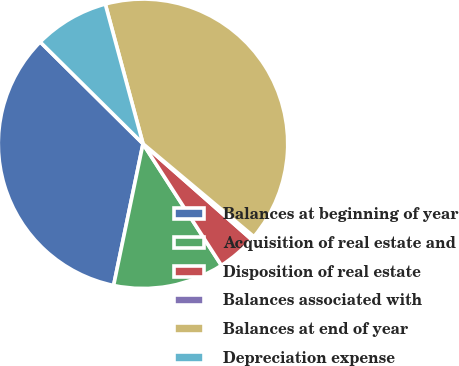Convert chart. <chart><loc_0><loc_0><loc_500><loc_500><pie_chart><fcel>Balances at beginning of year<fcel>Acquisition of real estate and<fcel>Disposition of real estate<fcel>Balances associated with<fcel>Balances at end of year<fcel>Depreciation expense<nl><fcel>34.17%<fcel>12.37%<fcel>4.39%<fcel>0.4%<fcel>40.3%<fcel>8.38%<nl></chart> 